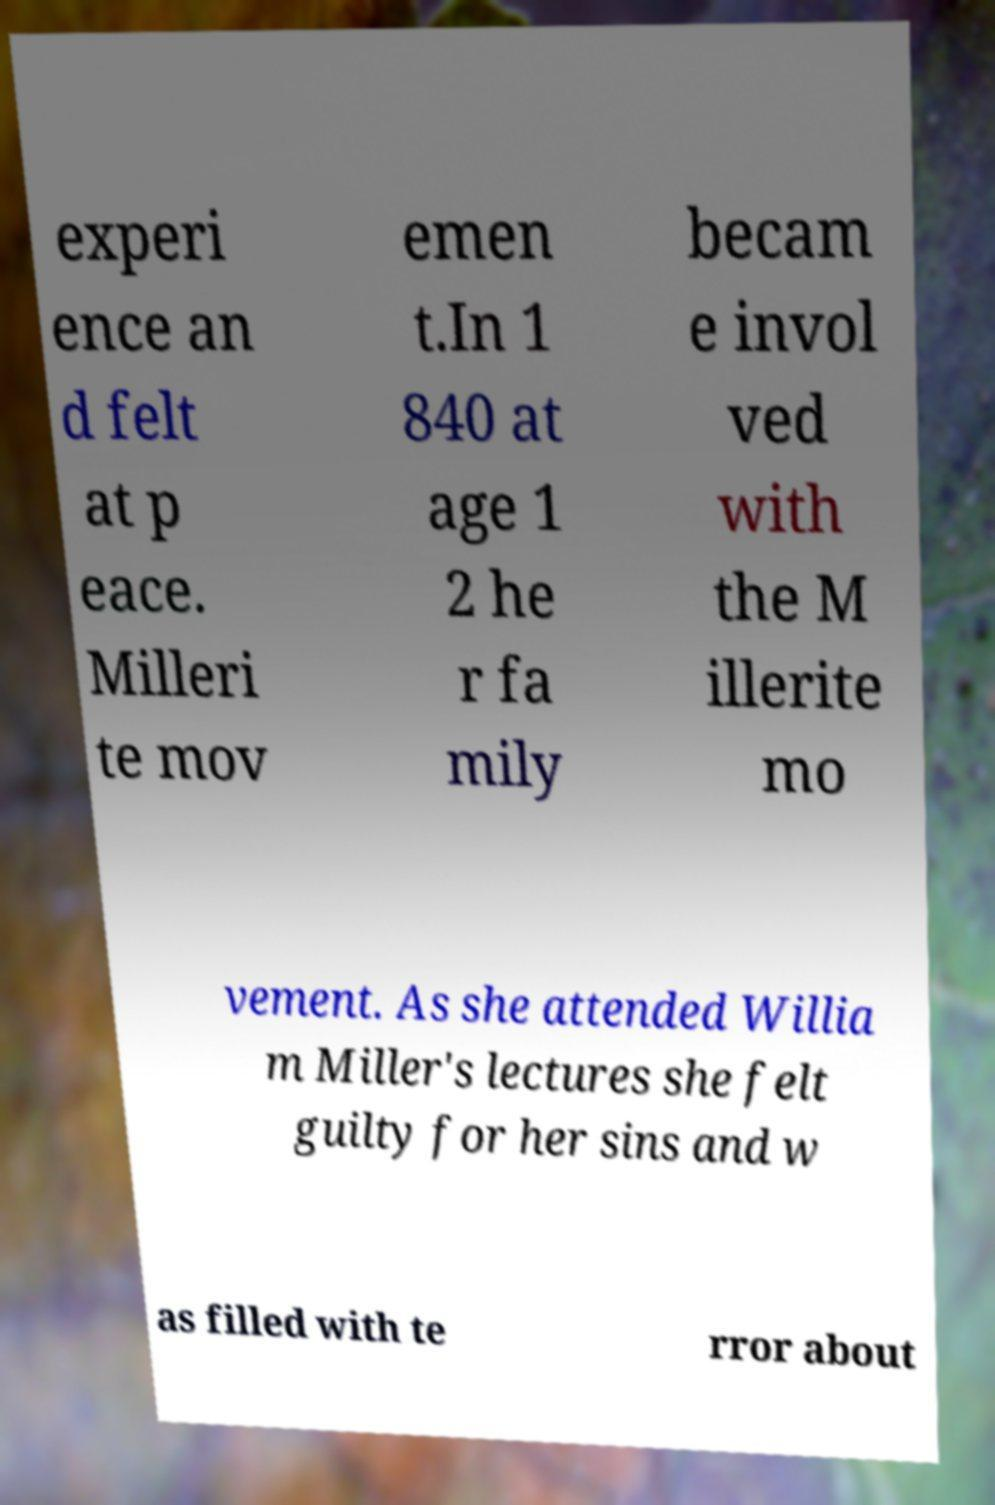For documentation purposes, I need the text within this image transcribed. Could you provide that? experi ence an d felt at p eace. Milleri te mov emen t.In 1 840 at age 1 2 he r fa mily becam e invol ved with the M illerite mo vement. As she attended Willia m Miller's lectures she felt guilty for her sins and w as filled with te rror about 